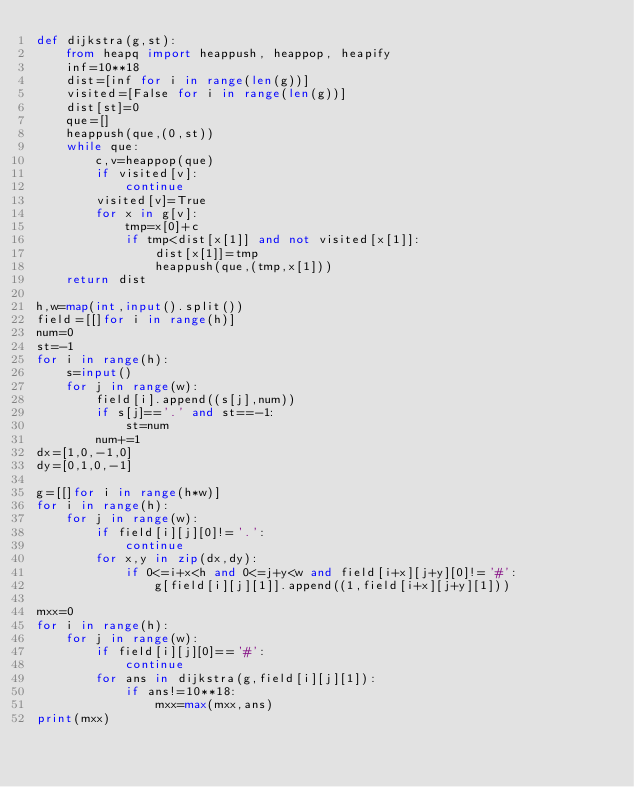<code> <loc_0><loc_0><loc_500><loc_500><_Python_>def dijkstra(g,st):
    from heapq import heappush, heappop, heapify
    inf=10**18
    dist=[inf for i in range(len(g))]
    visited=[False for i in range(len(g))]
    dist[st]=0
    que=[]
    heappush(que,(0,st))
    while que:
        c,v=heappop(que)
        if visited[v]:
            continue
        visited[v]=True
        for x in g[v]:
            tmp=x[0]+c
            if tmp<dist[x[1]] and not visited[x[1]]:
                dist[x[1]]=tmp
                heappush(que,(tmp,x[1]))
    return dist

h,w=map(int,input().split())
field=[[]for i in range(h)]
num=0
st=-1
for i in range(h):
    s=input()
    for j in range(w):
        field[i].append((s[j],num))
        if s[j]=='.' and st==-1:
            st=num
        num+=1
dx=[1,0,-1,0]
dy=[0,1,0,-1]

g=[[]for i in range(h*w)]
for i in range(h):
    for j in range(w):
        if field[i][j][0]!='.':
            continue
        for x,y in zip(dx,dy):
            if 0<=i+x<h and 0<=j+y<w and field[i+x][j+y][0]!='#':
                g[field[i][j][1]].append((1,field[i+x][j+y][1]))

mxx=0
for i in range(h):
    for j in range(w):
        if field[i][j][0]=='#':
            continue
        for ans in dijkstra(g,field[i][j][1]):
            if ans!=10**18:
                mxx=max(mxx,ans)
print(mxx)</code> 